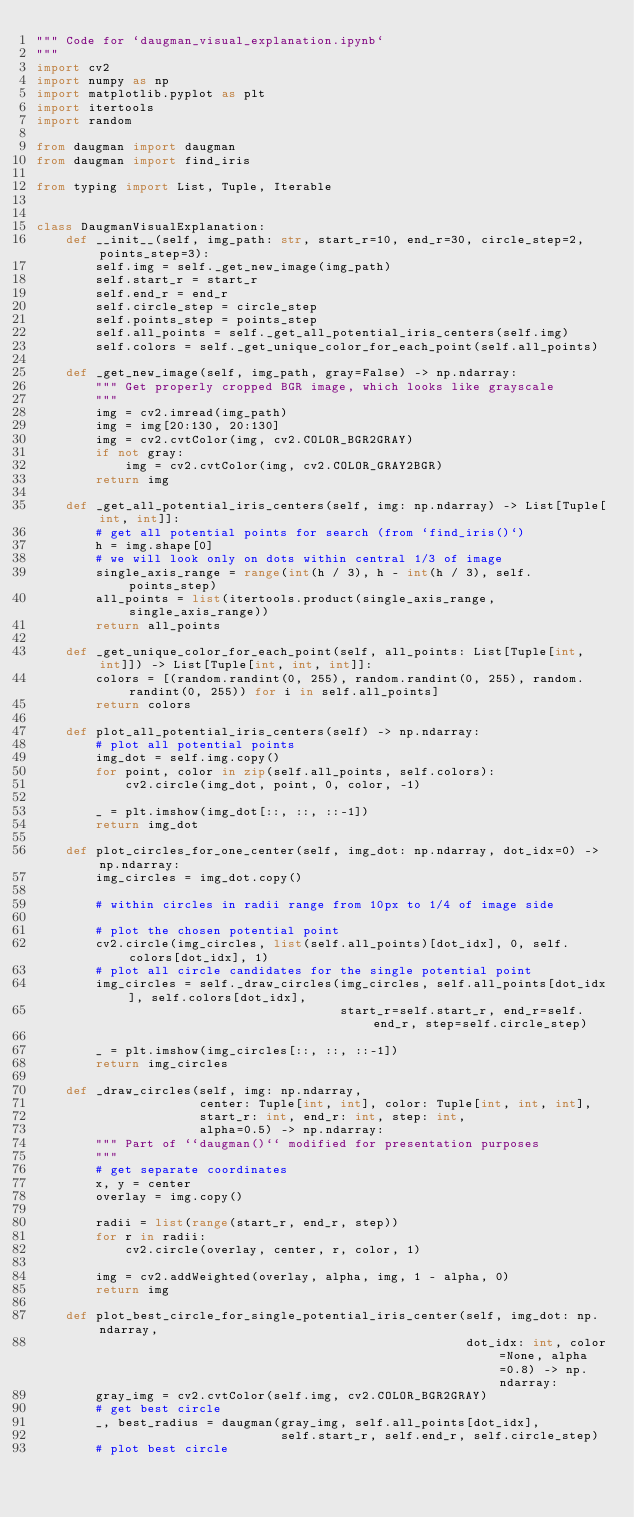<code> <loc_0><loc_0><loc_500><loc_500><_Python_>""" Code for `daugman_visual_explanation.ipynb`
"""
import cv2
import numpy as np
import matplotlib.pyplot as plt
import itertools
import random

from daugman import daugman
from daugman import find_iris

from typing import List, Tuple, Iterable


class DaugmanVisualExplanation:
    def __init__(self, img_path: str, start_r=10, end_r=30, circle_step=2, points_step=3):
        self.img = self._get_new_image(img_path)
        self.start_r = start_r
        self.end_r = end_r
        self.circle_step = circle_step
        self.points_step = points_step
        self.all_points = self._get_all_potential_iris_centers(self.img)
        self.colors = self._get_unique_color_for_each_point(self.all_points)

    def _get_new_image(self, img_path, gray=False) -> np.ndarray:
        """ Get properly cropped BGR image, which looks like grayscale
        """
        img = cv2.imread(img_path)
        img = img[20:130, 20:130]
        img = cv2.cvtColor(img, cv2.COLOR_BGR2GRAY)
        if not gray:
            img = cv2.cvtColor(img, cv2.COLOR_GRAY2BGR)
        return img

    def _get_all_potential_iris_centers(self, img: np.ndarray) -> List[Tuple[int, int]]:
        # get all potential points for search (from `find_iris()`)
        h = img.shape[0]
        # we will look only on dots within central 1/3 of image
        single_axis_range = range(int(h / 3), h - int(h / 3), self.points_step)
        all_points = list(itertools.product(single_axis_range, single_axis_range))
        return all_points

    def _get_unique_color_for_each_point(self, all_points: List[Tuple[int, int]]) -> List[Tuple[int, int, int]]:
        colors = [(random.randint(0, 255), random.randint(0, 255), random.randint(0, 255)) for i in self.all_points]
        return colors

    def plot_all_potential_iris_centers(self) -> np.ndarray:
        # plot all potential points
        img_dot = self.img.copy()
        for point, color in zip(self.all_points, self.colors):
            cv2.circle(img_dot, point, 0, color, -1)

        _ = plt.imshow(img_dot[::, ::, ::-1])
        return img_dot

    def plot_circles_for_one_center(self, img_dot: np.ndarray, dot_idx=0) -> np.ndarray:
        img_circles = img_dot.copy()

        # within circles in radii range from 10px to 1/4 of image side

        # plot the chosen potential point
        cv2.circle(img_circles, list(self.all_points)[dot_idx], 0, self.colors[dot_idx], 1)
        # plot all circle candidates for the single potential point
        img_circles = self._draw_circles(img_circles, self.all_points[dot_idx], self.colors[dot_idx],
                                         start_r=self.start_r, end_r=self.end_r, step=self.circle_step)

        _ = plt.imshow(img_circles[::, ::, ::-1])
        return img_circles

    def _draw_circles(self, img: np.ndarray,
                      center: Tuple[int, int], color: Tuple[int, int, int],
                      start_r: int, end_r: int, step: int,
                      alpha=0.5) -> np.ndarray:
        """ Part of ``daugman()`` modified for presentation purposes
        """
        # get separate coordinates
        x, y = center
        overlay = img.copy()

        radii = list(range(start_r, end_r, step))
        for r in radii:
            cv2.circle(overlay, center, r, color, 1)

        img = cv2.addWeighted(overlay, alpha, img, 1 - alpha, 0)
        return img

    def plot_best_circle_for_single_potential_iris_center(self, img_dot: np.ndarray,
                                                          dot_idx: int, color=None, alpha=0.8) -> np.ndarray:
        gray_img = cv2.cvtColor(self.img, cv2.COLOR_BGR2GRAY)
        # get best circle
        _, best_radius = daugman(gray_img, self.all_points[dot_idx],
                                 self.start_r, self.end_r, self.circle_step)
        # plot best circle</code> 